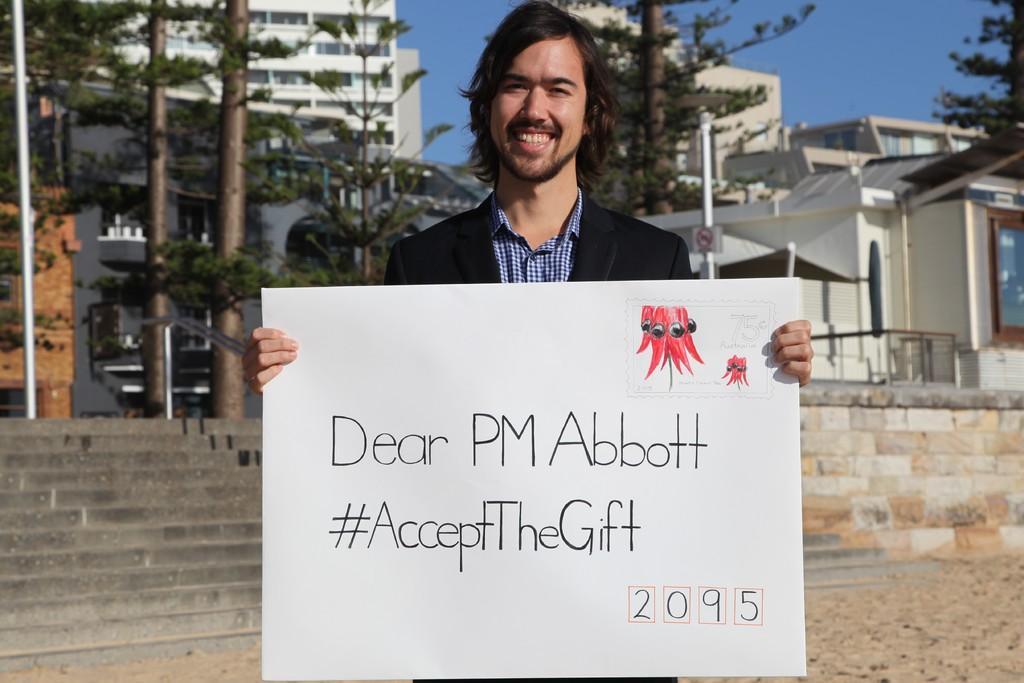Could you give a brief overview of what you see in this image? In this image I can see a man holding a poster. There are stairs, trees, poles and buildings at the back. There is sky at the top. 